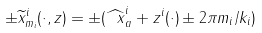<formula> <loc_0><loc_0><loc_500><loc_500>\pm \widetilde { x } ^ { i } _ { m _ { i } } ( \cdot , z ) = \pm ( \widehat { \ x } _ { a } ^ { i } + z ^ { i } ( \cdot ) \pm 2 \pi m _ { i } / k _ { i } )</formula> 